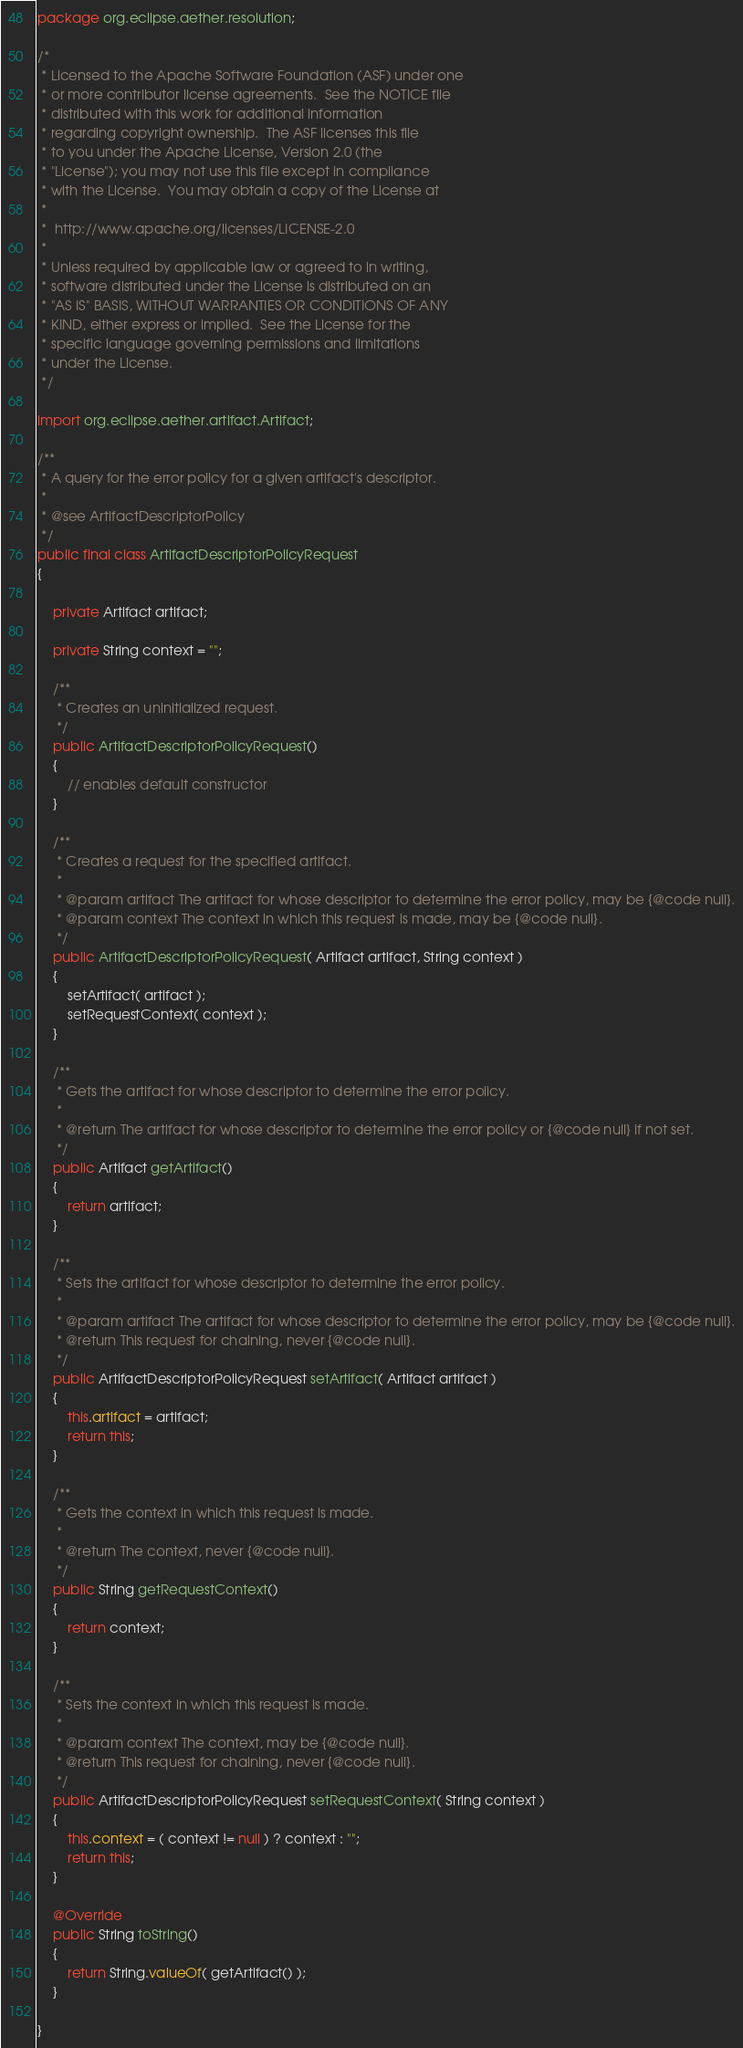<code> <loc_0><loc_0><loc_500><loc_500><_Java_>package org.eclipse.aether.resolution;

/*
 * Licensed to the Apache Software Foundation (ASF) under one
 * or more contributor license agreements.  See the NOTICE file
 * distributed with this work for additional information
 * regarding copyright ownership.  The ASF licenses this file
 * to you under the Apache License, Version 2.0 (the
 * "License"); you may not use this file except in compliance
 * with the License.  You may obtain a copy of the License at
 * 
 *  http://www.apache.org/licenses/LICENSE-2.0
 * 
 * Unless required by applicable law or agreed to in writing,
 * software distributed under the License is distributed on an
 * "AS IS" BASIS, WITHOUT WARRANTIES OR CONDITIONS OF ANY
 * KIND, either express or implied.  See the License for the
 * specific language governing permissions and limitations
 * under the License.
 */

import org.eclipse.aether.artifact.Artifact;

/**
 * A query for the error policy for a given artifact's descriptor.
 * 
 * @see ArtifactDescriptorPolicy
 */
public final class ArtifactDescriptorPolicyRequest
{

    private Artifact artifact;

    private String context = "";

    /**
     * Creates an uninitialized request.
     */
    public ArtifactDescriptorPolicyRequest()
    {
        // enables default constructor
    }

    /**
     * Creates a request for the specified artifact.
     * 
     * @param artifact The artifact for whose descriptor to determine the error policy, may be {@code null}.
     * @param context The context in which this request is made, may be {@code null}.
     */
    public ArtifactDescriptorPolicyRequest( Artifact artifact, String context )
    {
        setArtifact( artifact );
        setRequestContext( context );
    }

    /**
     * Gets the artifact for whose descriptor to determine the error policy.
     * 
     * @return The artifact for whose descriptor to determine the error policy or {@code null} if not set.
     */
    public Artifact getArtifact()
    {
        return artifact;
    }

    /**
     * Sets the artifact for whose descriptor to determine the error policy.
     * 
     * @param artifact The artifact for whose descriptor to determine the error policy, may be {@code null}.
     * @return This request for chaining, never {@code null}.
     */
    public ArtifactDescriptorPolicyRequest setArtifact( Artifact artifact )
    {
        this.artifact = artifact;
        return this;
    }

    /**
     * Gets the context in which this request is made.
     * 
     * @return The context, never {@code null}.
     */
    public String getRequestContext()
    {
        return context;
    }

    /**
     * Sets the context in which this request is made.
     * 
     * @param context The context, may be {@code null}.
     * @return This request for chaining, never {@code null}.
     */
    public ArtifactDescriptorPolicyRequest setRequestContext( String context )
    {
        this.context = ( context != null ) ? context : "";
        return this;
    }

    @Override
    public String toString()
    {
        return String.valueOf( getArtifact() );
    }

}
</code> 